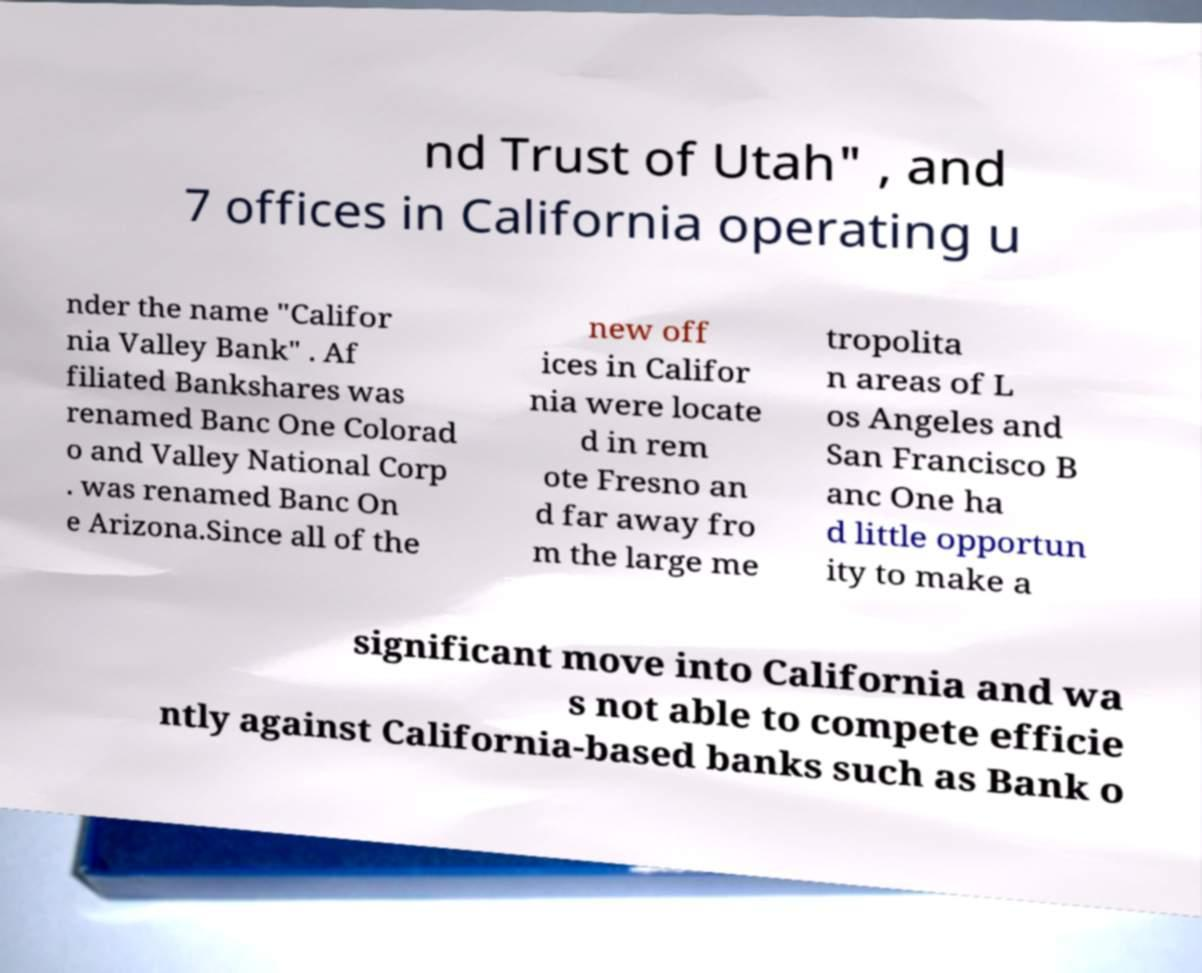Can you read and provide the text displayed in the image?This photo seems to have some interesting text. Can you extract and type it out for me? nd Trust of Utah" , and 7 offices in California operating u nder the name "Califor nia Valley Bank" . Af filiated Bankshares was renamed Banc One Colorad o and Valley National Corp . was renamed Banc On e Arizona.Since all of the new off ices in Califor nia were locate d in rem ote Fresno an d far away fro m the large me tropolita n areas of L os Angeles and San Francisco B anc One ha d little opportun ity to make a significant move into California and wa s not able to compete efficie ntly against California-based banks such as Bank o 